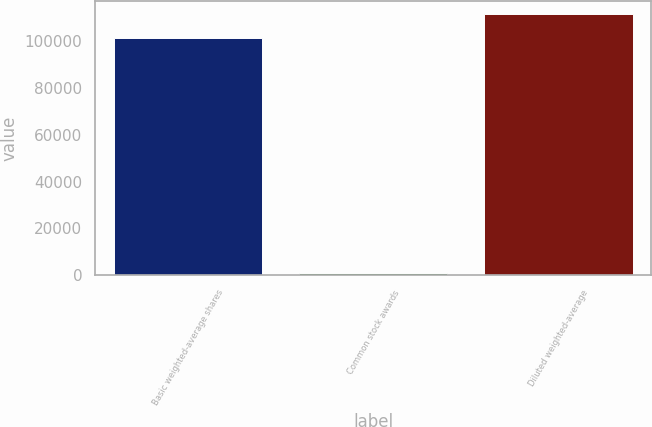Convert chart. <chart><loc_0><loc_0><loc_500><loc_500><bar_chart><fcel>Basic weighted-average shares<fcel>Common stock awards<fcel>Diluted weighted-average<nl><fcel>101291<fcel>1126<fcel>111425<nl></chart> 